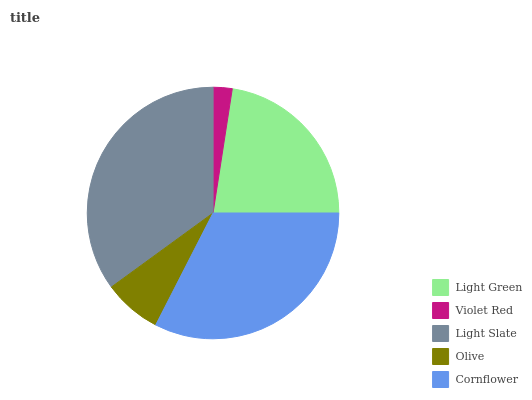Is Violet Red the minimum?
Answer yes or no. Yes. Is Light Slate the maximum?
Answer yes or no. Yes. Is Light Slate the minimum?
Answer yes or no. No. Is Violet Red the maximum?
Answer yes or no. No. Is Light Slate greater than Violet Red?
Answer yes or no. Yes. Is Violet Red less than Light Slate?
Answer yes or no. Yes. Is Violet Red greater than Light Slate?
Answer yes or no. No. Is Light Slate less than Violet Red?
Answer yes or no. No. Is Light Green the high median?
Answer yes or no. Yes. Is Light Green the low median?
Answer yes or no. Yes. Is Violet Red the high median?
Answer yes or no. No. Is Light Slate the low median?
Answer yes or no. No. 